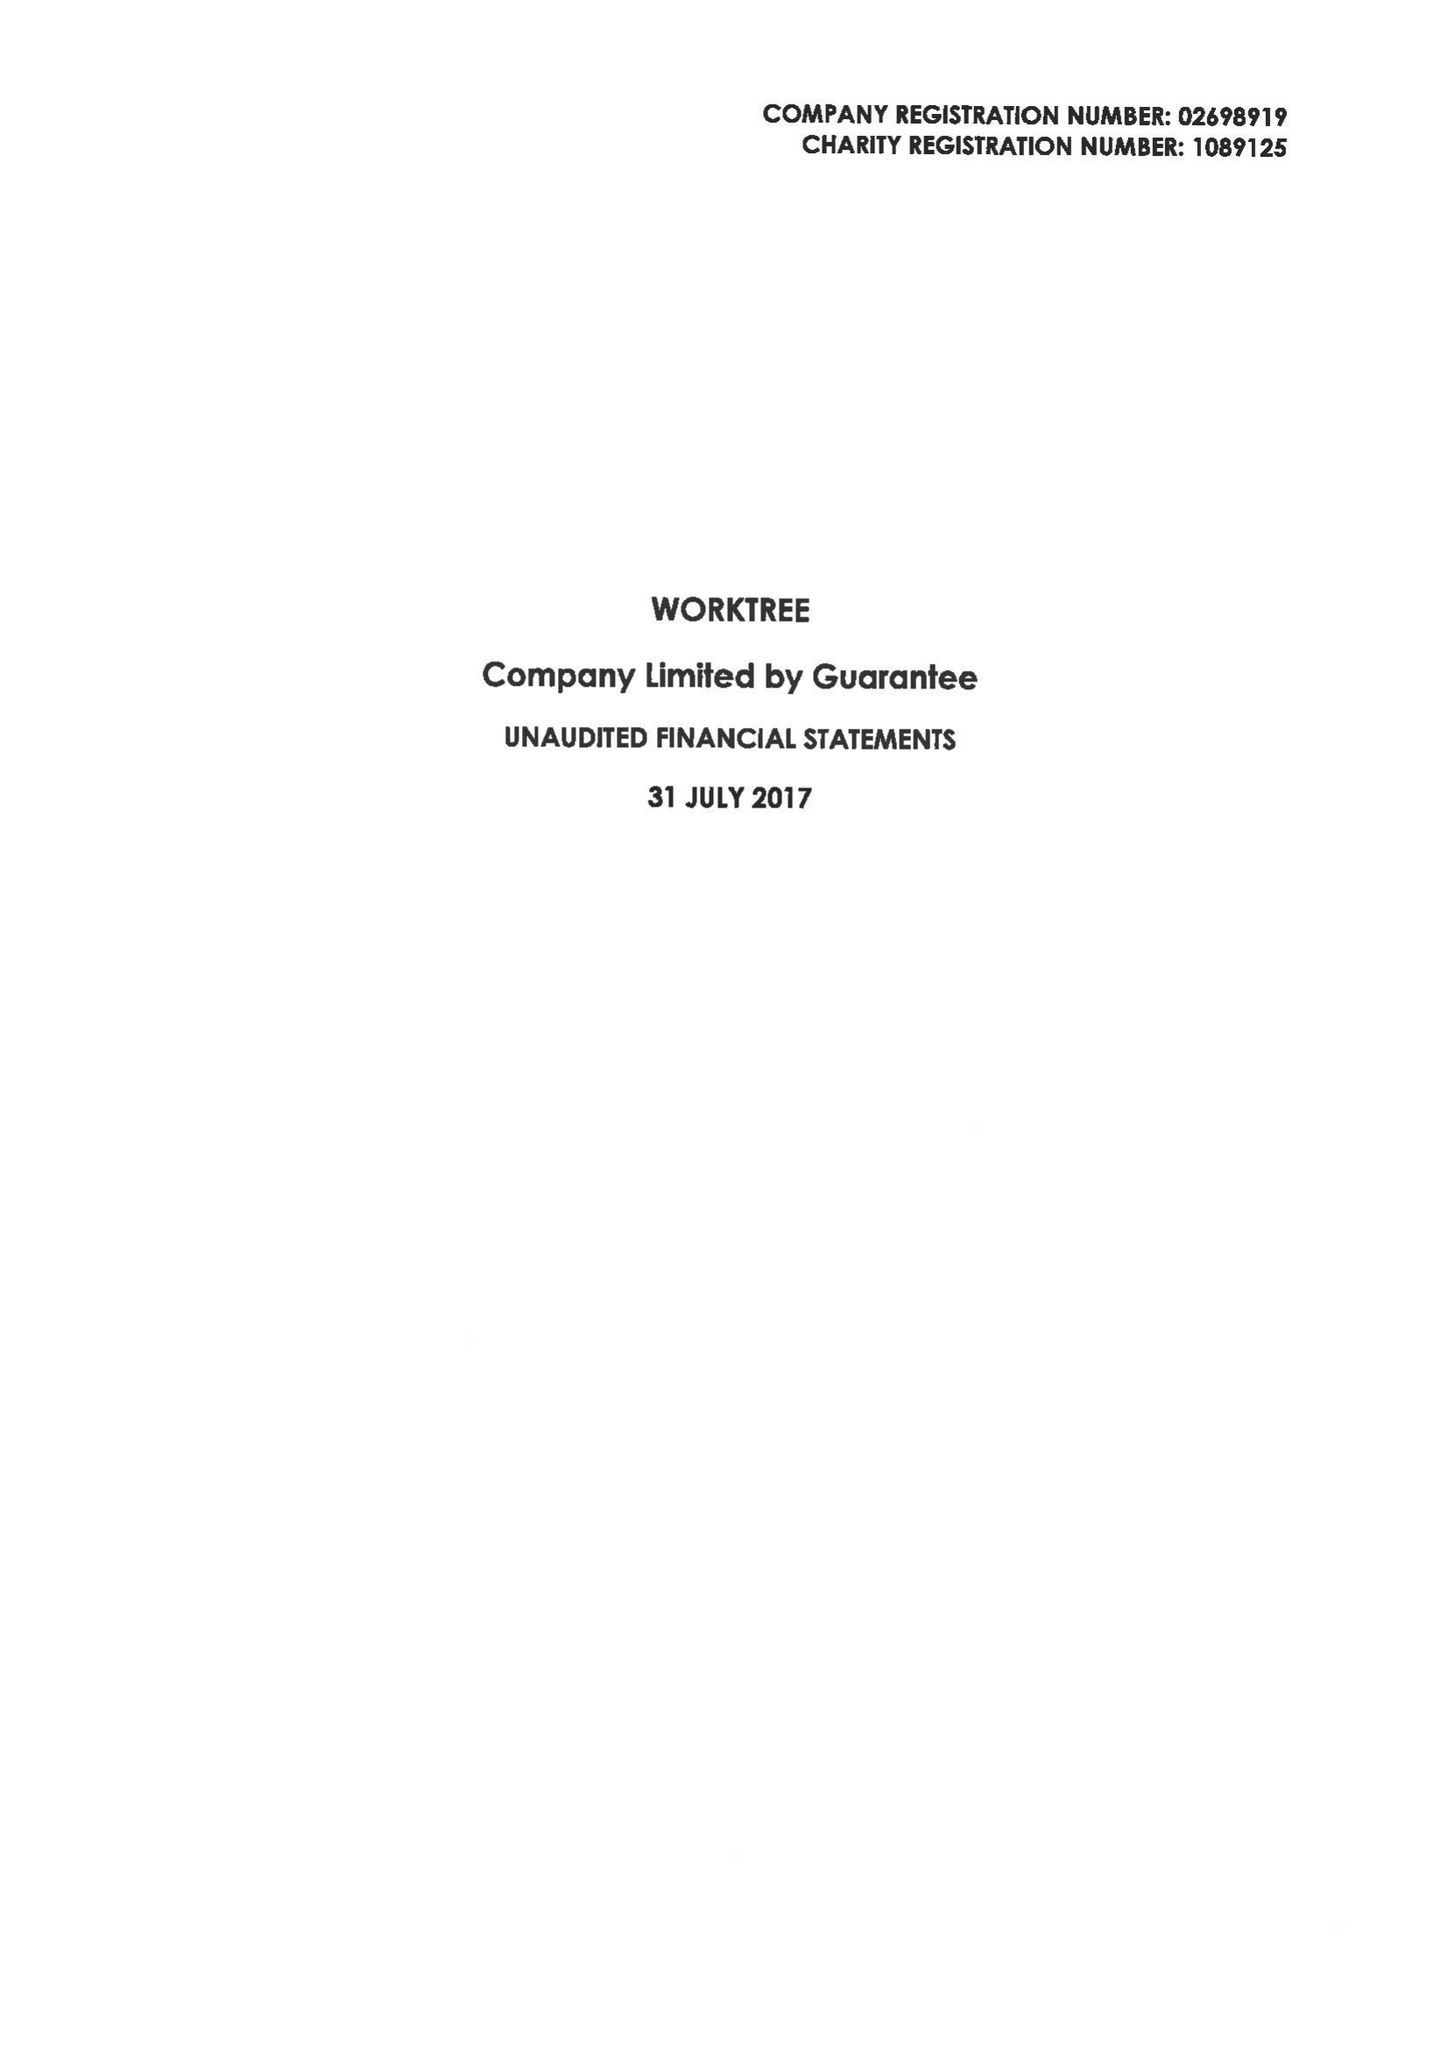What is the value for the report_date?
Answer the question using a single word or phrase. 2017-07-31 